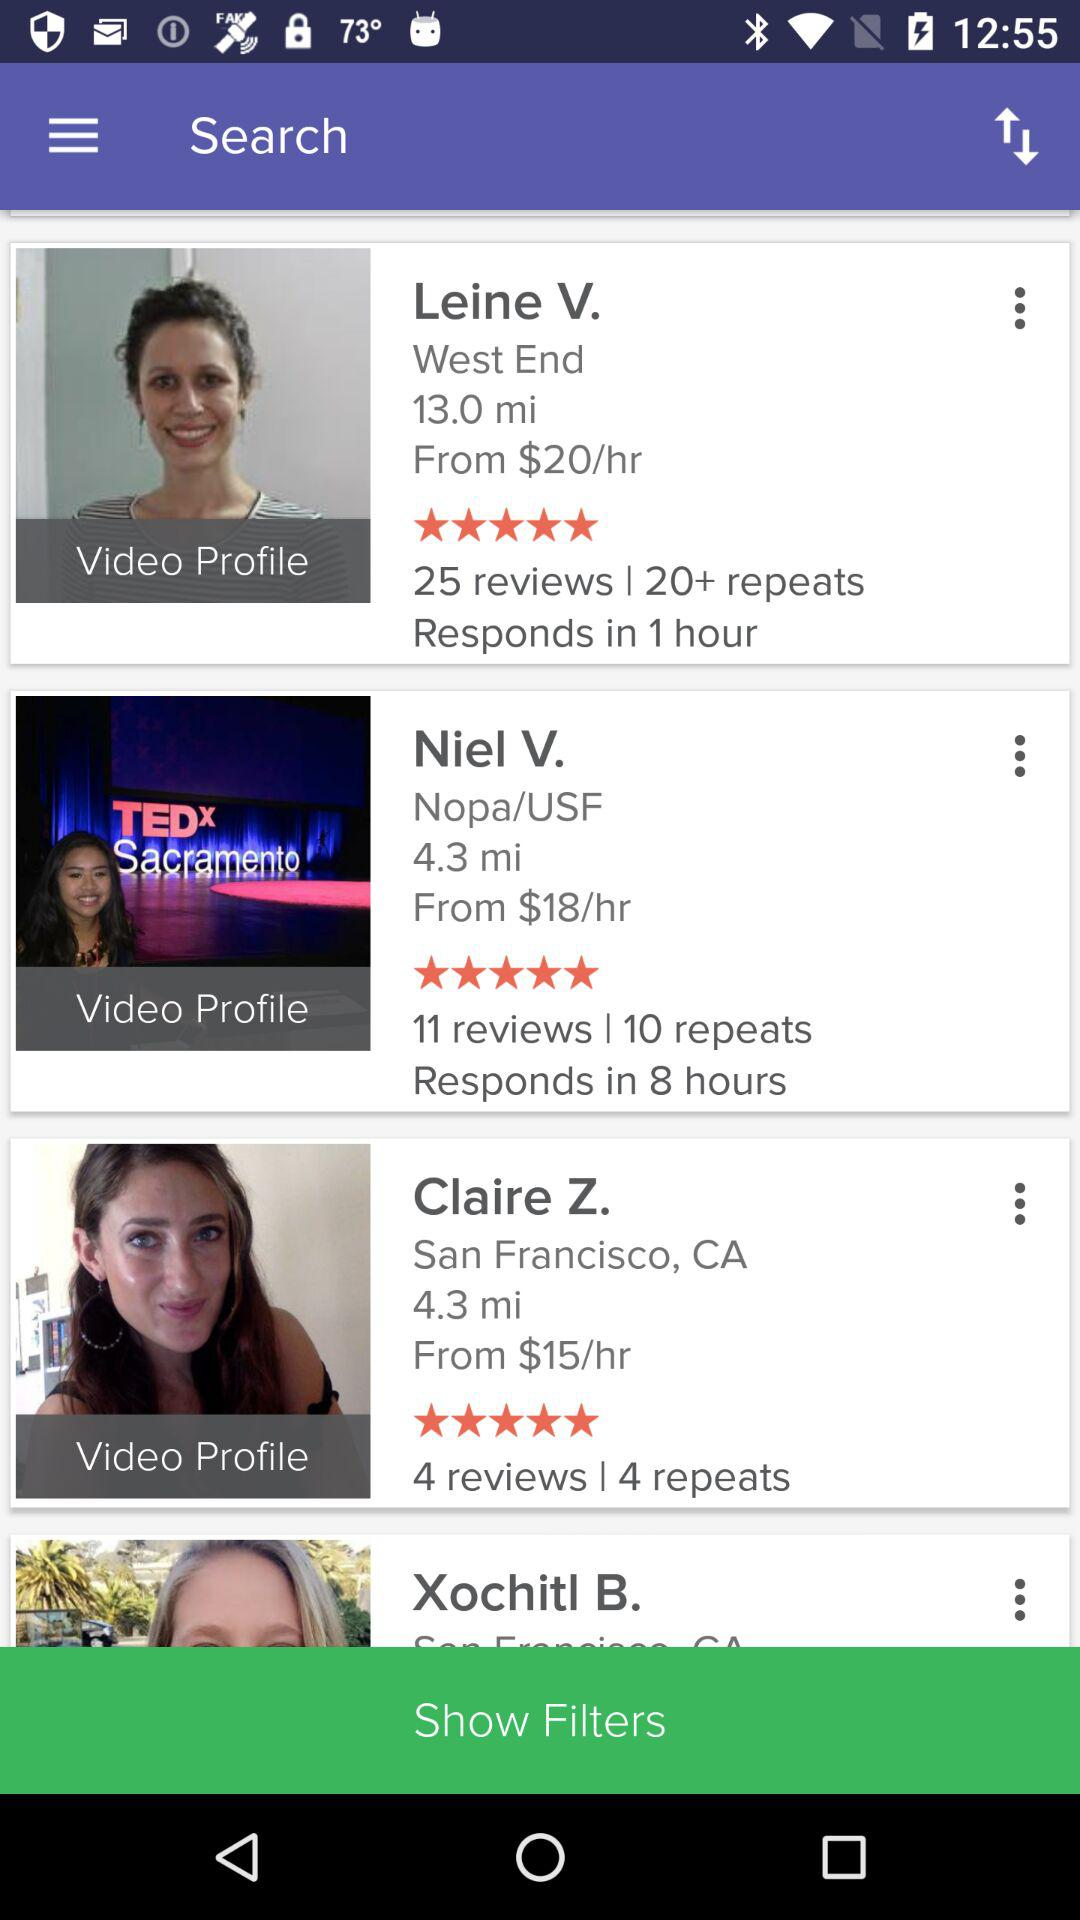Which user responds in 8 hours? The user that responds in 8 hours is Niel V. 